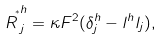<formula> <loc_0><loc_0><loc_500><loc_500>\overset { \ _ { * } } R ^ { h } _ { j } = \kappa F ^ { 2 } ( \delta ^ { h } _ { j } - l ^ { h } l _ { j } ) ,</formula> 